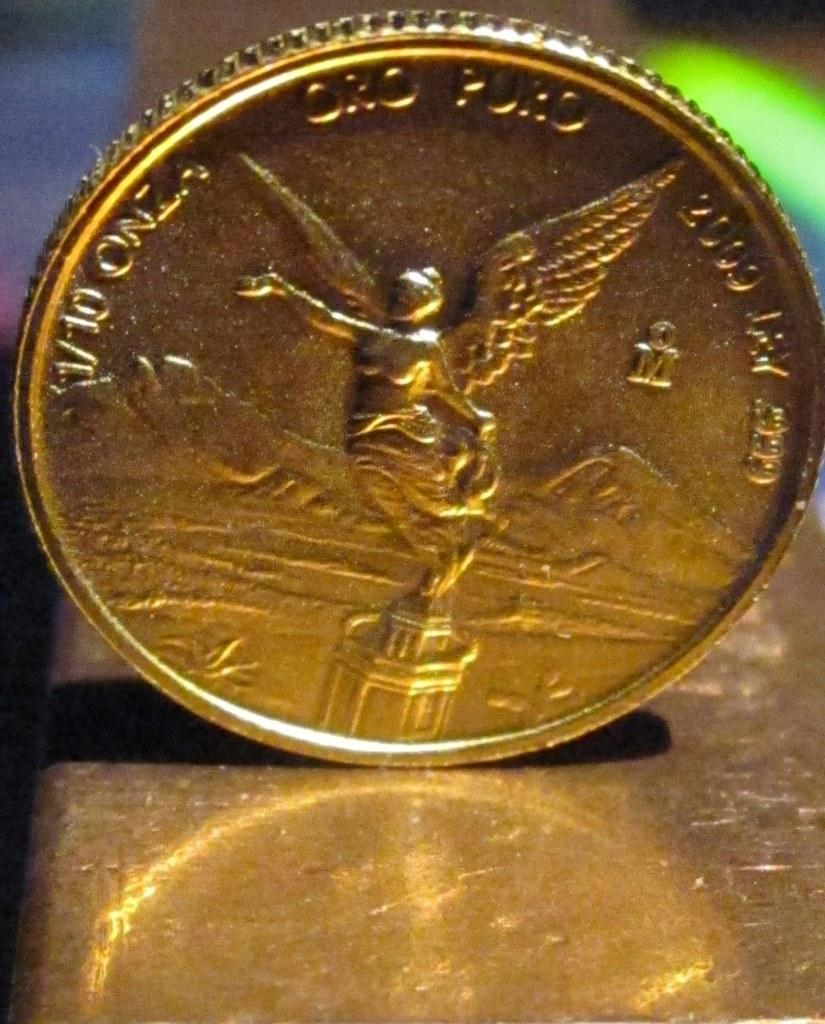<image>
Create a compact narrative representing the image presented. A gold coin has an inscription V10 Onza on the left hand side. 